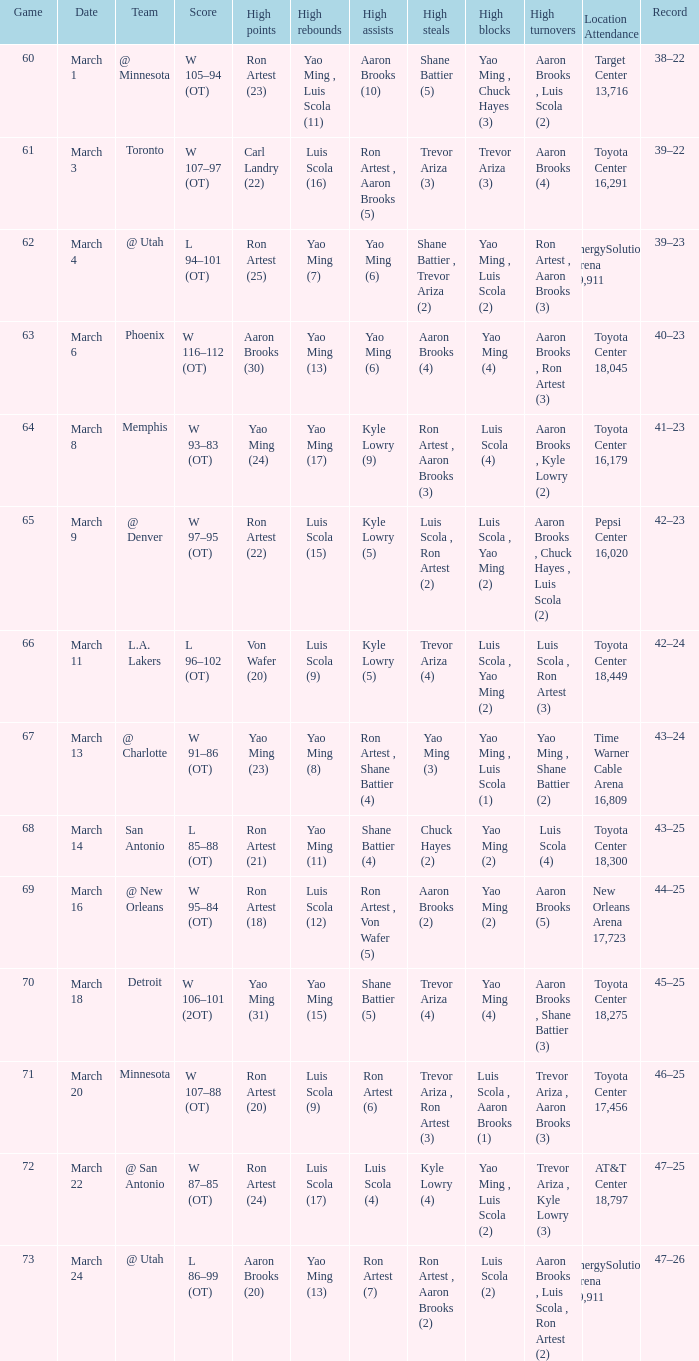Who had the most poinst in game 72? Ron Artest (24). 